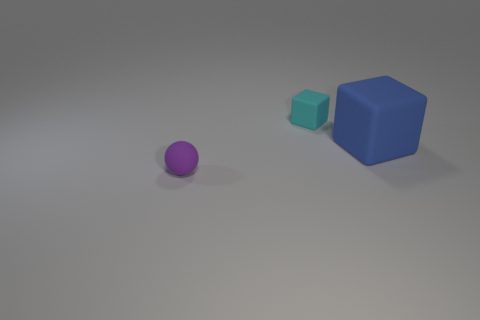Add 3 tiny purple matte spheres. How many objects exist? 6 Subtract all spheres. How many objects are left? 2 Add 1 yellow cylinders. How many yellow cylinders exist? 1 Subtract 0 purple cubes. How many objects are left? 3 Subtract all big purple blocks. Subtract all large blue objects. How many objects are left? 2 Add 2 balls. How many balls are left? 3 